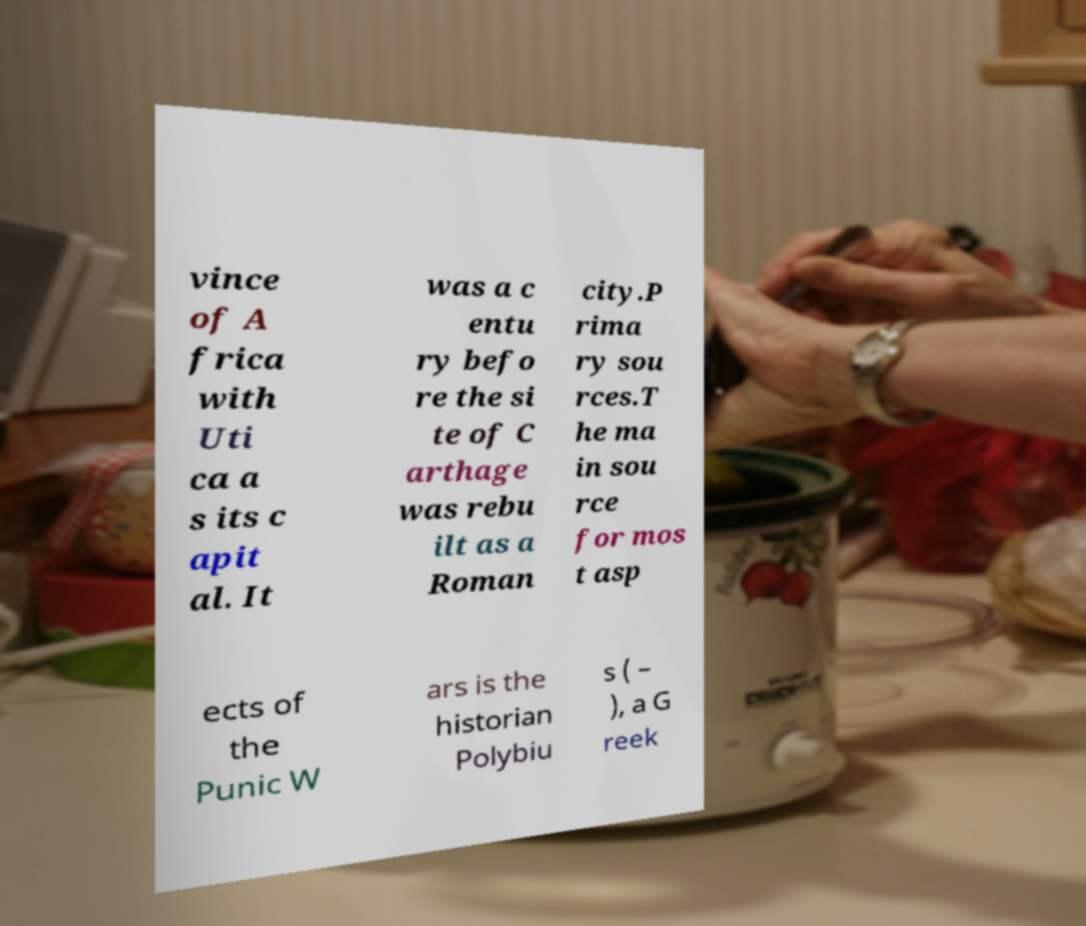I need the written content from this picture converted into text. Can you do that? vince of A frica with Uti ca a s its c apit al. It was a c entu ry befo re the si te of C arthage was rebu ilt as a Roman city.P rima ry sou rces.T he ma in sou rce for mos t asp ects of the Punic W ars is the historian Polybiu s ( – ), a G reek 